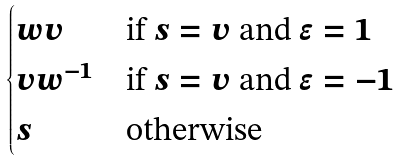Convert formula to latex. <formula><loc_0><loc_0><loc_500><loc_500>\begin{cases} w v & \text {if $s=v$ and $\epsilon=1$} \\ v w ^ { - 1 } & \text {if $s=v$ and $\epsilon=-1$} \\ s & \text {otherwise} \end{cases}</formula> 